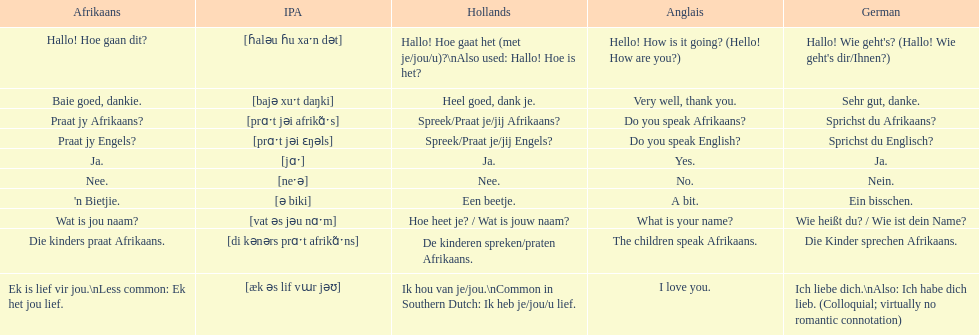Give me the full table as a dictionary. {'header': ['Afrikaans', 'IPA', 'Hollands', 'Anglais', 'German'], 'rows': [['Hallo! Hoe gaan dit?', '[ɦaləu ɦu xaˑn dət]', 'Hallo! Hoe gaat het (met je/jou/u)?\\nAlso used: Hallo! Hoe is het?', 'Hello! How is it going? (Hello! How are you?)', "Hallo! Wie geht's? (Hallo! Wie geht's dir/Ihnen?)"], ['Baie goed, dankie.', '[bajə xuˑt daŋki]', 'Heel goed, dank je.', 'Very well, thank you.', 'Sehr gut, danke.'], ['Praat jy Afrikaans?', '[prɑˑt jəi afrikɑ̃ˑs]', 'Spreek/Praat je/jij Afrikaans?', 'Do you speak Afrikaans?', 'Sprichst du Afrikaans?'], ['Praat jy Engels?', '[prɑˑt jəi ɛŋəls]', 'Spreek/Praat je/jij Engels?', 'Do you speak English?', 'Sprichst du Englisch?'], ['Ja.', '[jɑˑ]', 'Ja.', 'Yes.', 'Ja.'], ['Nee.', '[neˑə]', 'Nee.', 'No.', 'Nein.'], ["'n Bietjie.", '[ə biki]', 'Een beetje.', 'A bit.', 'Ein bisschen.'], ['Wat is jou naam?', '[vat əs jəu nɑˑm]', 'Hoe heet je? / Wat is jouw naam?', 'What is your name?', 'Wie heißt du? / Wie ist dein Name?'], ['Die kinders praat Afrikaans.', '[di kənərs prɑˑt afrikɑ̃ˑns]', 'De kinderen spreken/praten Afrikaans.', 'The children speak Afrikaans.', 'Die Kinder sprechen Afrikaans.'], ['Ek is lief vir jou.\\nLess common: Ek het jou lief.', '[æk əs lif vɯr jəʊ]', 'Ik hou van je/jou.\\nCommon in Southern Dutch: Ik heb je/jou/u lief.', 'I love you.', 'Ich liebe dich.\\nAlso: Ich habe dich lieb. (Colloquial; virtually no romantic connotation)']]} Translate the following into german: die kinders praat afrikaans. Die Kinder sprechen Afrikaans. 